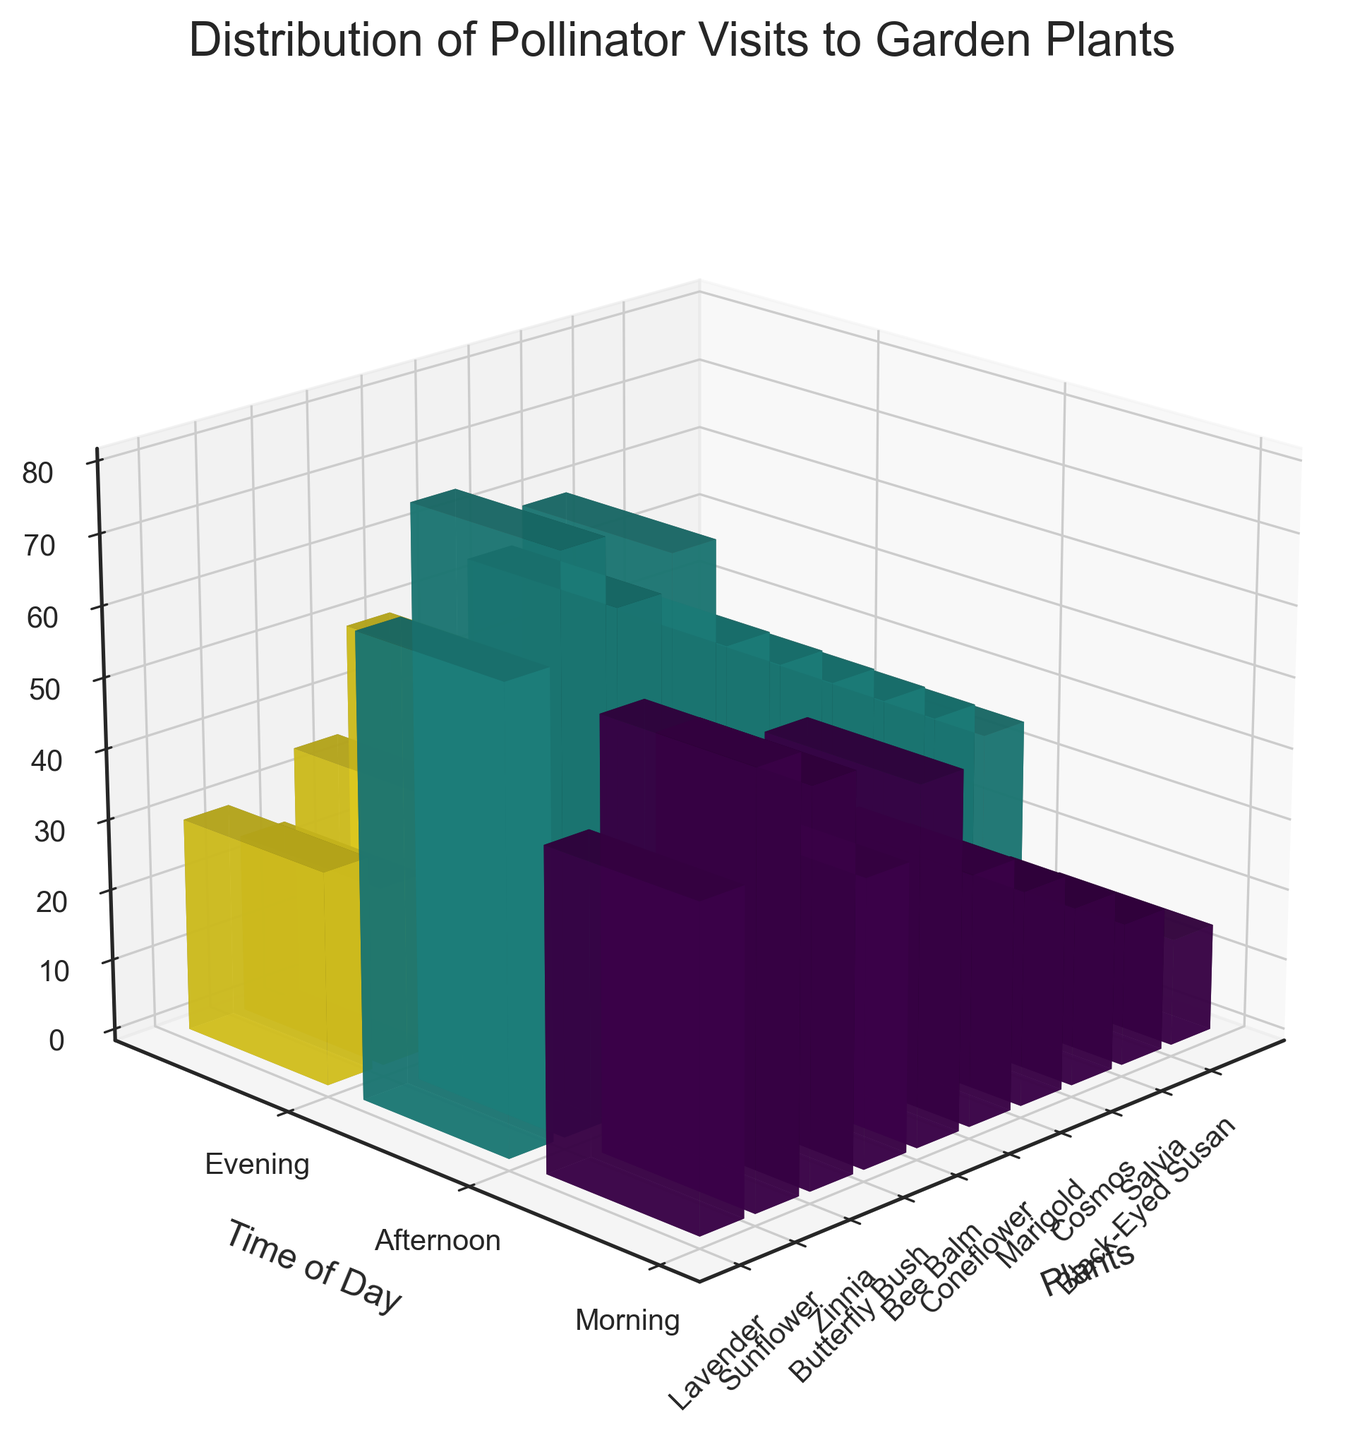What's the title of the figure? The title of the figure can be found at the top, which usually summarizes the content of the plot.
Answer: Distribution of Pollinator Visits to Garden Plants What does the z-axis represent? The label of the z-axis will provide the information about what it measures.
Answer: Number of Pollinator Visits Which plant had the highest number of pollinator visits in the afternoon? Look at the bars for each plant in the 'Afternoon' group and identify the highest one.
Answer: Butterfly Bush What is the combined number of pollinator visits to Sunflower and Zinnia in the morning? First, locate the number of visits for Sunflower and Zinnia in the morning. Then sum these numbers: Sunflower (60) + Zinnia (55).
Answer: 115 During which time of day did the pollinators visit the Marigold the least? Compare the heights of the bars representing the Marigold for Morning, Afternoon, and Evening time periods. Identify the shortest one.
Answer: Evening Which plant had more visits in the morning, Bee Balm or Butterfly Bush? Compare the height of the 'Morning' bar for Bee Balm and Butterfly Bush.
Answer: Bee Balm Which time of day generally had the lowest number of visits across all plants? Compare the overall height of bars across all plants for Morning, Afternoon, and Evening. Identify the time of day with the shortest bars overall.
Answer: Evening How many plants had more than 50 visits in the afternoon? Check the number of visits for each plant in the afternoon and count how many have visit counts greater than 50: Lavender (65), Sunflower (80), Zinnia (70), Butterfly Bush (75), Bee Balm (60), Coneflower (55).
Answer: 6 Which plant had the biggest increase in pollinator visits from morning to afternoon? Calculate the difference between morning and afternoon visits for each plant and identify the one with the largest increase:
Lavender: 65-45 = 20,
Sunflower: 80-60 = 20,
Zinnia: 70-55 = 15,
Butterfly Bush: 75-40 = 35,
Bee Balm: 60-50 = 10,
Coneflower: 55-35 = 20,
Marigold: 50-30 = 20,
Cosmos: 45-25 = 20,
Salvia: 40-20 = 20,
Black-Eyed Susan: 35-15 = 20,
The largest increase is for Butterfly Bush with 35.
Answer: Butterfly Bush 